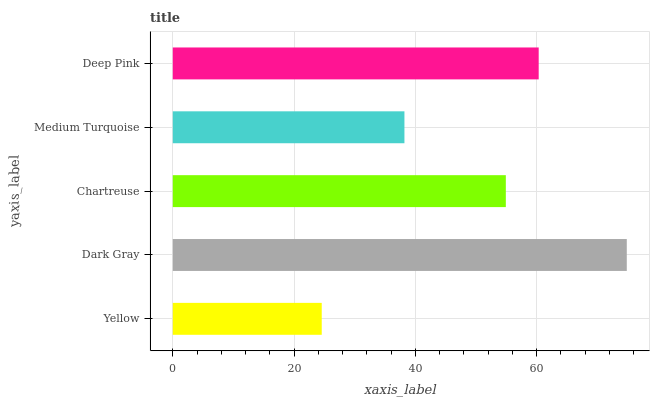Is Yellow the minimum?
Answer yes or no. Yes. Is Dark Gray the maximum?
Answer yes or no. Yes. Is Chartreuse the minimum?
Answer yes or no. No. Is Chartreuse the maximum?
Answer yes or no. No. Is Dark Gray greater than Chartreuse?
Answer yes or no. Yes. Is Chartreuse less than Dark Gray?
Answer yes or no. Yes. Is Chartreuse greater than Dark Gray?
Answer yes or no. No. Is Dark Gray less than Chartreuse?
Answer yes or no. No. Is Chartreuse the high median?
Answer yes or no. Yes. Is Chartreuse the low median?
Answer yes or no. Yes. Is Dark Gray the high median?
Answer yes or no. No. Is Medium Turquoise the low median?
Answer yes or no. No. 